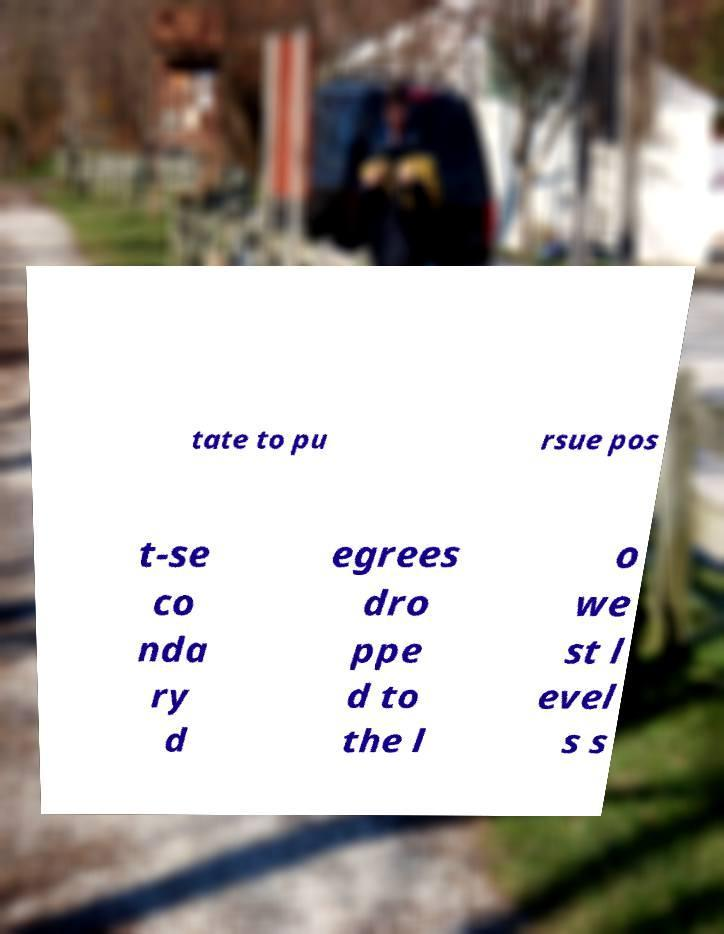Could you extract and type out the text from this image? tate to pu rsue pos t-se co nda ry d egrees dro ppe d to the l o we st l evel s s 